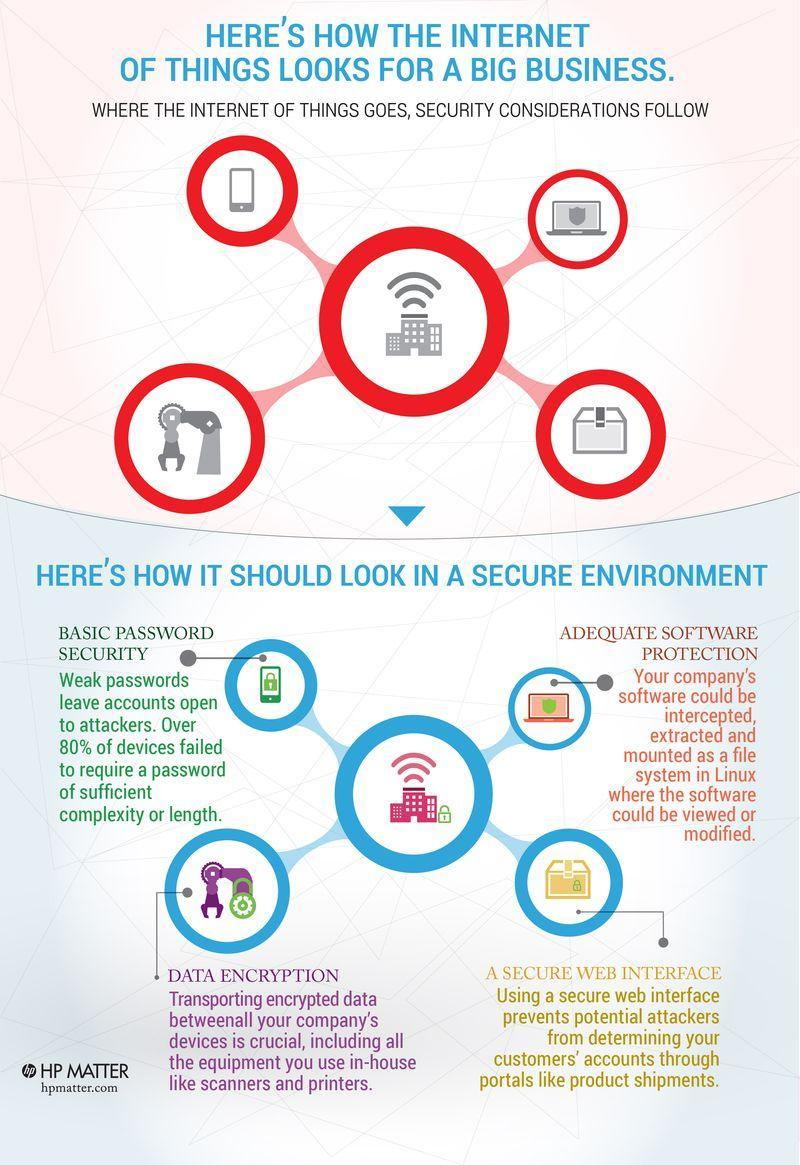What percentage of devices lacked strong and complex passwords?
Answer the question with a short phrase. 80% 